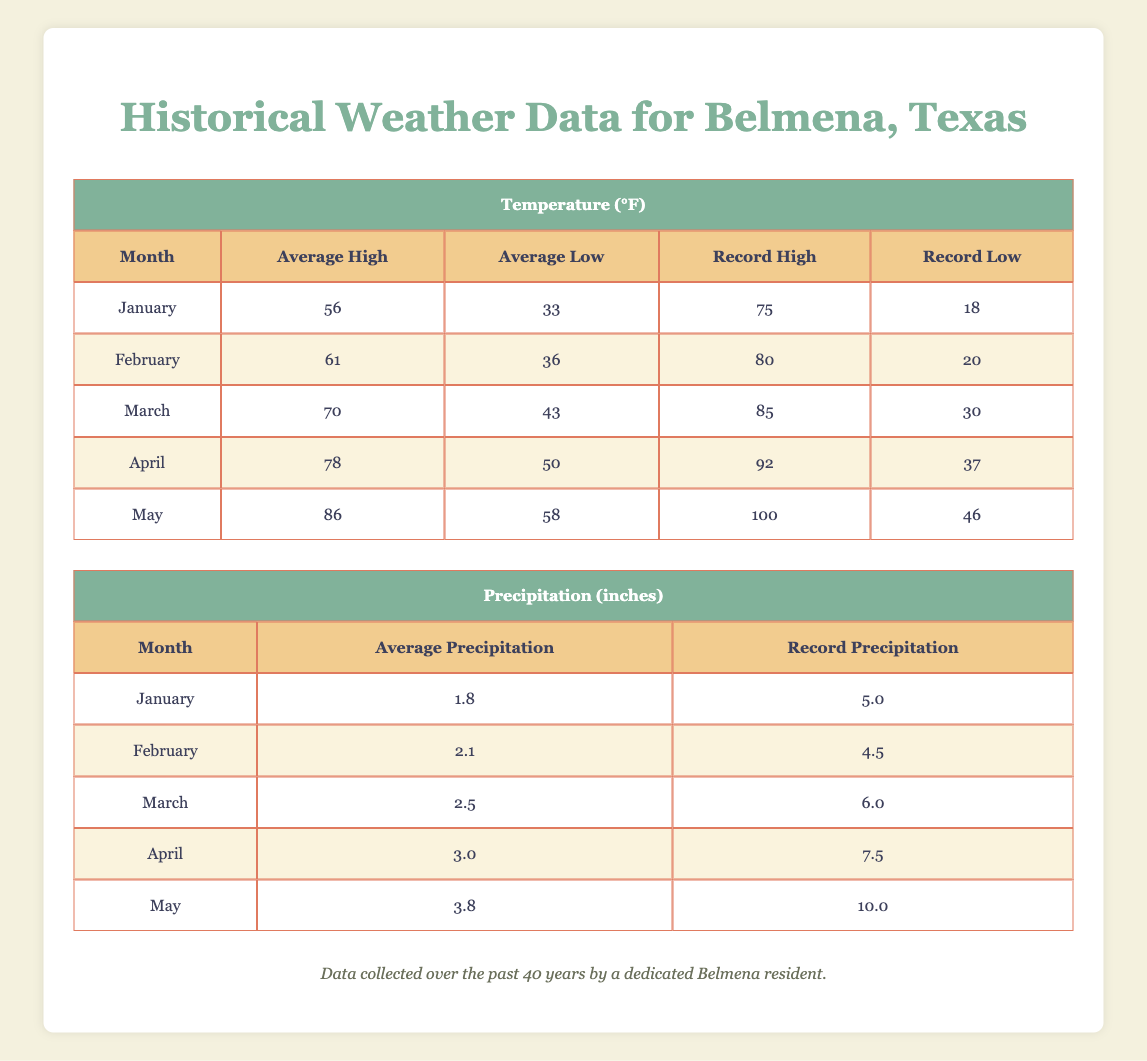What is the average high temperature in January? According to the table, the Average High temperature in January is listed directly in the Temperature section for January, which is 56 °F.
Answer: 56 °F What was the record low temperature in March? The table displays the Record Low temperature for March in the temperature section. It shows that the Record Low was 30 °F.
Answer: 30 °F How much average precipitation falls in May? The Average Precipitation for May is given in the precipitation section of the table as 3.8 inches.
Answer: 3.8 inches Which month has the highest average low temperature? Looking in the Temperature section, we compare the Average Low values for each month. May has an Average Low of 58 °F, which is the highest among the listed months.
Answer: May What is the difference between the record high and record low temperatures in April? The Record High temperature in April is 92 °F and the Record Low is 37 °F. To find the difference, subtract the Record Low from the Record High: 92 - 37 = 55.
Answer: 55 °F Is the record precipitation for April greater than the average precipitation for the same month? The Record Precipitation for April is 7.5 inches, while the Average Precipitation is 3.0 inches. Since 7.5 is greater than 3.0, the statement is true.
Answer: Yes What is the total average precipitation from January to March? The Average Precipitation values for January (1.8), February (2.1), and March (2.5) need to be summed: 1.8 + 2.1 + 2.5 = 6.4 inches.
Answer: 6.4 inches Which month has the largest record precipitation value? Upon examining the Record Precipitation values for each month, May has the highest value at 10.0 inches, which is greater than any other month's record precipitation.
Answer: May What is the average high temperature for the first quarter of the year (January to March)? To determine this average, first sum the Average High temperatures for January (56), February (61), and March (70): 56 + 61 + 70 = 187. Then divide by the number of months (3): 187 / 3 = 62.33.
Answer: 62.33 °F 